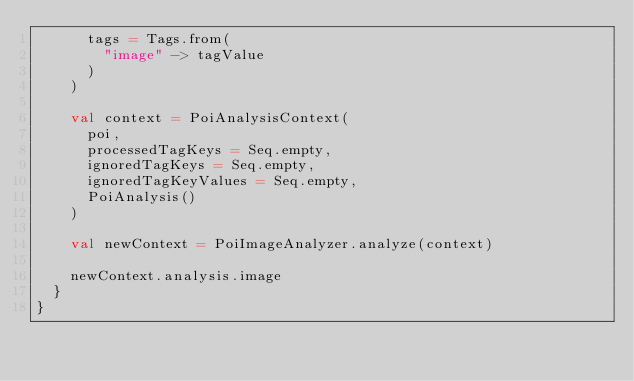<code> <loc_0><loc_0><loc_500><loc_500><_Scala_>      tags = Tags.from(
        "image" -> tagValue
      )
    )

    val context = PoiAnalysisContext(
      poi,
      processedTagKeys = Seq.empty,
      ignoredTagKeys = Seq.empty,
      ignoredTagKeyValues = Seq.empty,
      PoiAnalysis()
    )

    val newContext = PoiImageAnalyzer.analyze(context)

    newContext.analysis.image
  }
}
</code> 